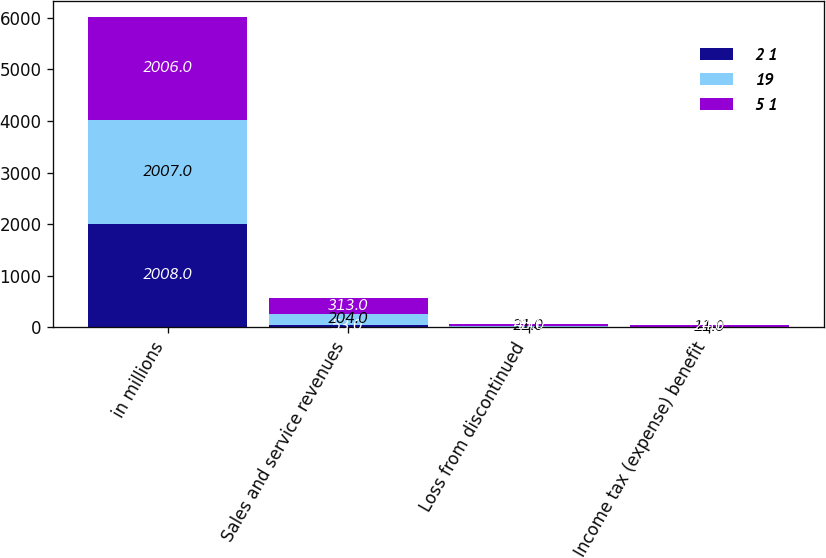Convert chart to OTSL. <chart><loc_0><loc_0><loc_500><loc_500><stacked_bar_chart><ecel><fcel>in millions<fcel>Sales and service revenues<fcel>Loss from discontinued<fcel>Income tax (expense) benefit<nl><fcel>2 1<fcel>2008<fcel>53<fcel>7<fcel>1<nl><fcel>19<fcel>2007<fcel>204<fcel>21<fcel>11<nl><fcel>5 1<fcel>2006<fcel>313<fcel>45<fcel>24<nl></chart> 